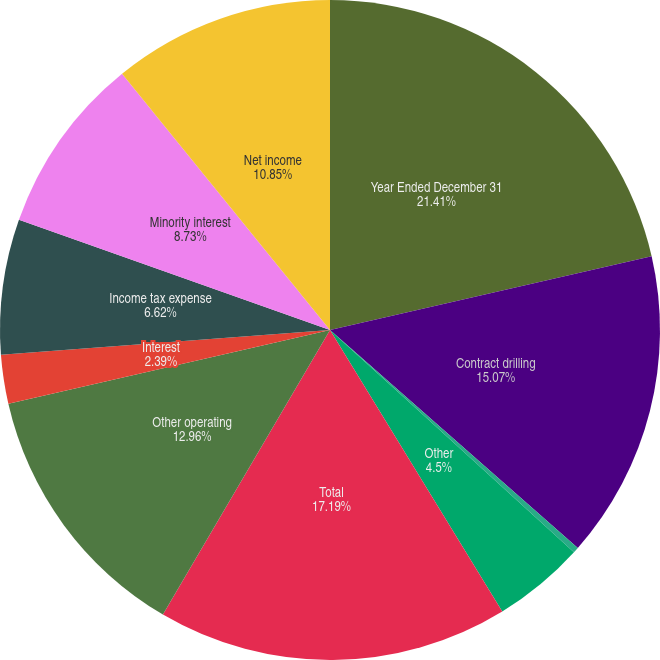Convert chart. <chart><loc_0><loc_0><loc_500><loc_500><pie_chart><fcel>Year Ended December 31<fcel>Contract drilling<fcel>Net investment income<fcel>Other<fcel>Total<fcel>Other operating<fcel>Interest<fcel>Income tax expense<fcel>Minority interest<fcel>Net income<nl><fcel>21.41%<fcel>15.07%<fcel>0.28%<fcel>4.5%<fcel>17.19%<fcel>12.96%<fcel>2.39%<fcel>6.62%<fcel>8.73%<fcel>10.85%<nl></chart> 